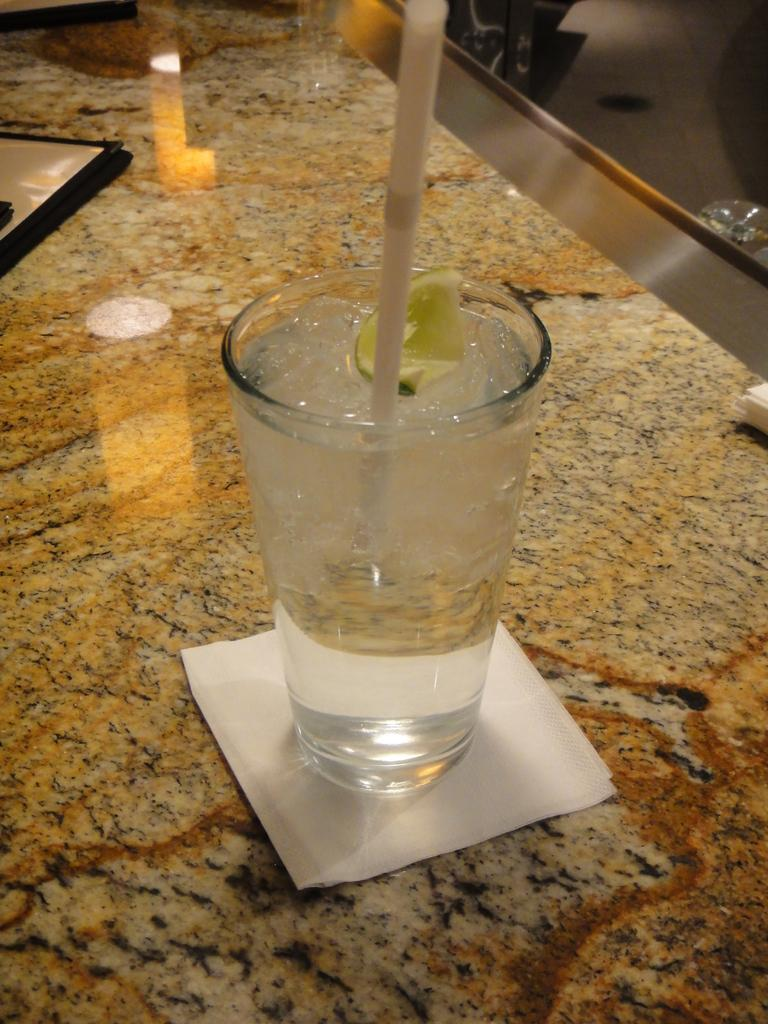What object is present in the image that can hold liquid? There is a glass in the image that can hold liquid. What is the glass placed on in the image? The glass is on a paper in the image. What is used to drink the liquid from the glass? There is a straw in the glass in the image. What type of oatmeal is being served on the plate in the image? There is no plate or oatmeal present in the image; it only features a glass on a paper with a straw in it. 